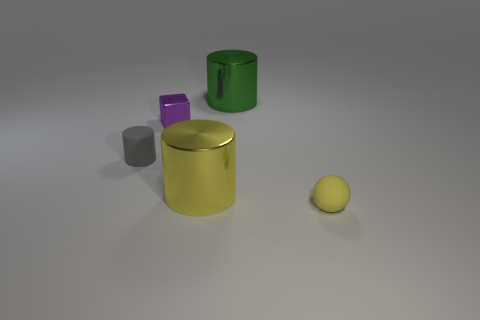Subtract all metal cylinders. How many cylinders are left? 1 Subtract all spheres. How many objects are left? 4 Add 5 gray rubber cylinders. How many objects exist? 10 Add 1 tiny purple metal cubes. How many tiny purple metal cubes are left? 2 Add 3 tiny blue objects. How many tiny blue objects exist? 3 Subtract 0 brown cylinders. How many objects are left? 5 Subtract all small matte cylinders. Subtract all small rubber cubes. How many objects are left? 4 